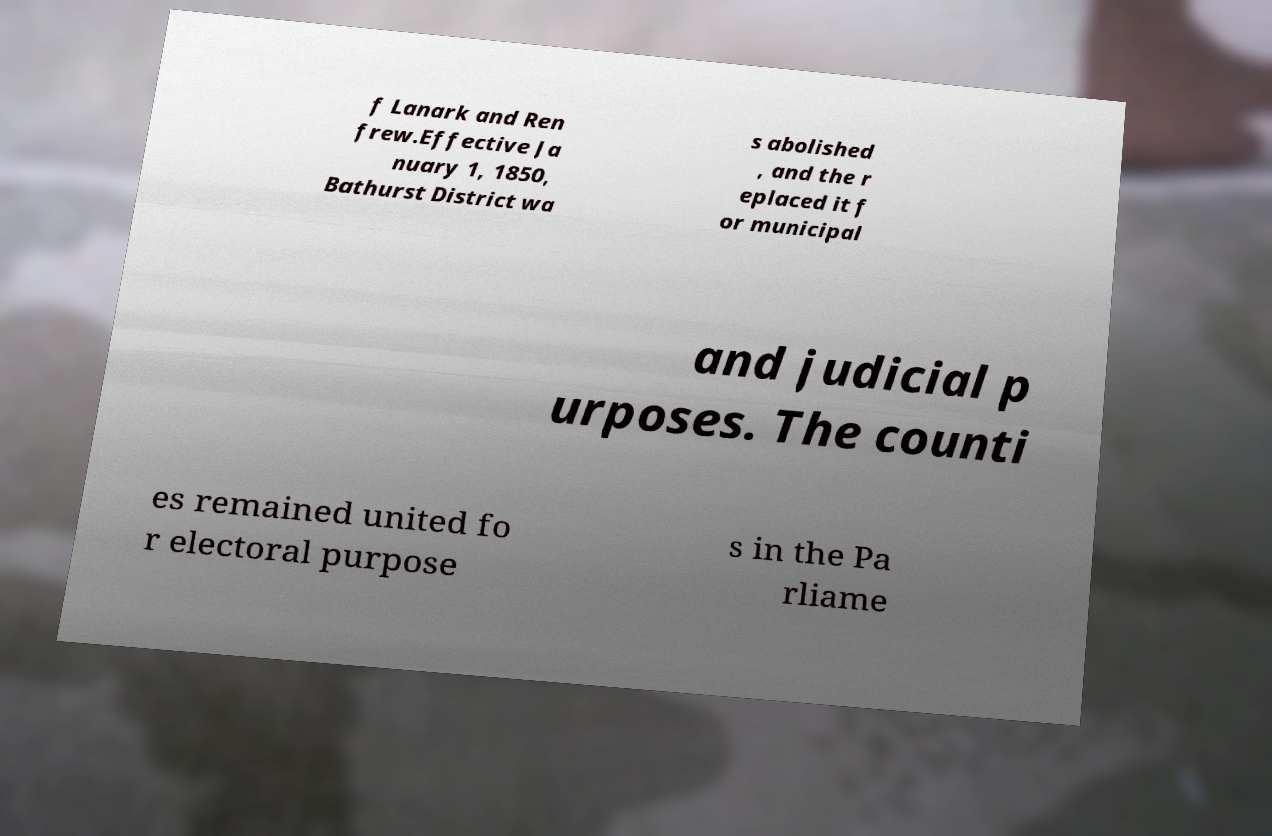Could you extract and type out the text from this image? f Lanark and Ren frew.Effective Ja nuary 1, 1850, Bathurst District wa s abolished , and the r eplaced it f or municipal and judicial p urposes. The counti es remained united fo r electoral purpose s in the Pa rliame 